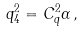<formula> <loc_0><loc_0><loc_500><loc_500>q _ { 4 } ^ { 2 } = C _ { q } ^ { 2 } \alpha \, ,</formula> 